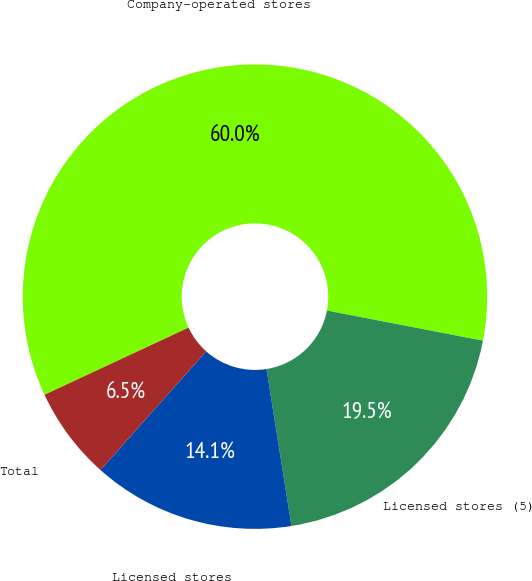<chart> <loc_0><loc_0><loc_500><loc_500><pie_chart><fcel>Company-operated stores<fcel>Licensed stores (5)<fcel>Licensed stores<fcel>Total<nl><fcel>59.98%<fcel>19.45%<fcel>14.1%<fcel>6.47%<nl></chart> 